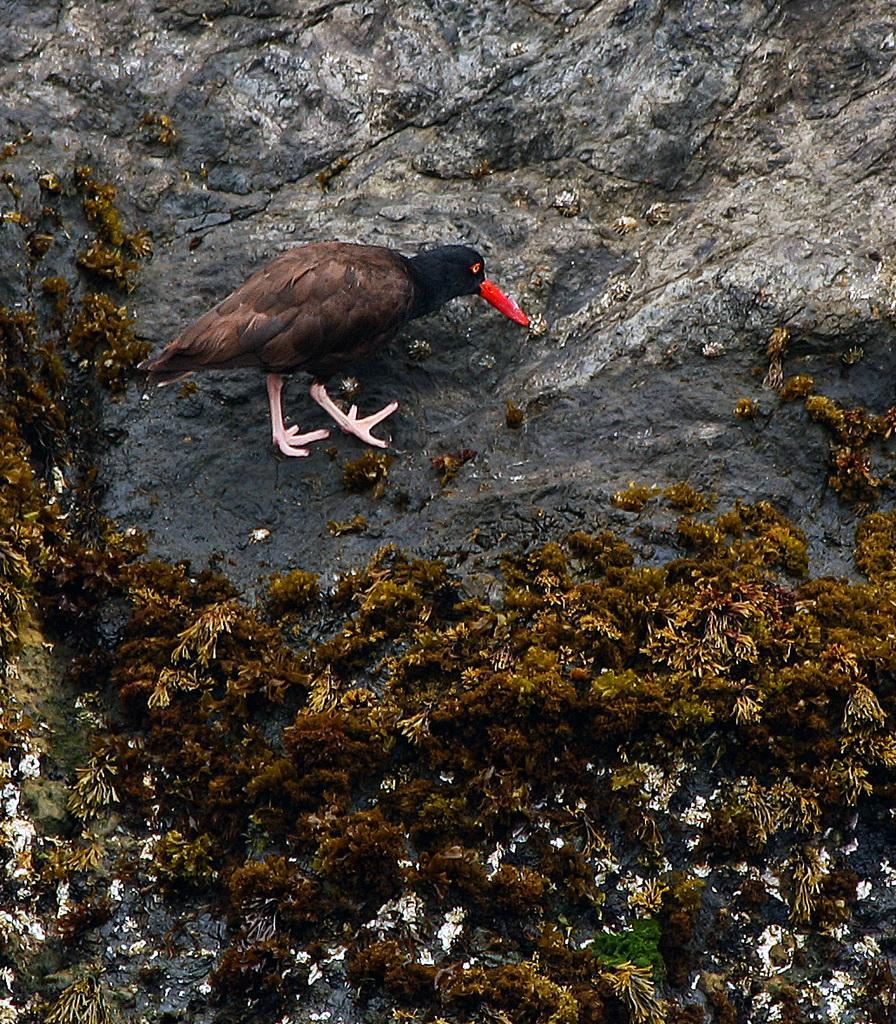What type of vegetation is at the bottom of the image? There is grass at the bottom of the image. What animal can be seen in the middle of the image? There is a bird in the middle of the image. What type of object is visible in the image? There is a stone visible in the image. What type of shock can be seen in the image? There is no shock present in the image. How is the distribution of the bird in the image? The bird is located in the middle of the image, and there is no need to describe its distribution. 